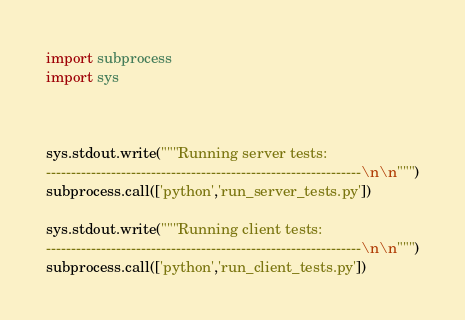<code> <loc_0><loc_0><loc_500><loc_500><_Python_>import subprocess
import sys



sys.stdout.write("""Running server tests:
---------------------------------------------------------------\n\n""")
subprocess.call(['python','run_server_tests.py'])

sys.stdout.write("""Running client tests:
---------------------------------------------------------------\n\n""")
subprocess.call(['python','run_client_tests.py'])
</code> 